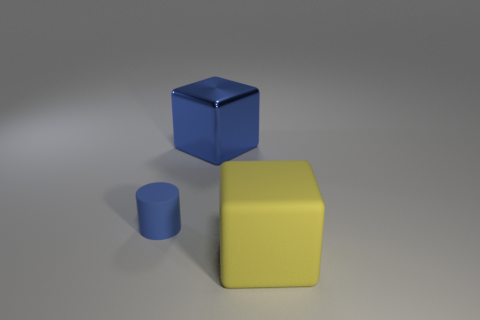Can you speculate on the size relationships between the objects? The size relationships between the objects suggest that the large yellow cube is the biggest among them, potentially a few inches in dimension. The blue cylinder is smaller, possibly half the height of the yellow cube. The blue cube looks to be the smallest, perhaps a cubic inch or so, given its proportion relative to the other objects and assuming they are all relatively close together in space. 